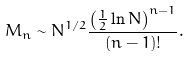Convert formula to latex. <formula><loc_0><loc_0><loc_500><loc_500>M _ { n } \sim N ^ { 1 / 2 } \frac { \left ( \frac { 1 } { 2 } \ln N \right ) ^ { n - 1 } } { ( n - 1 ) ! } .</formula> 